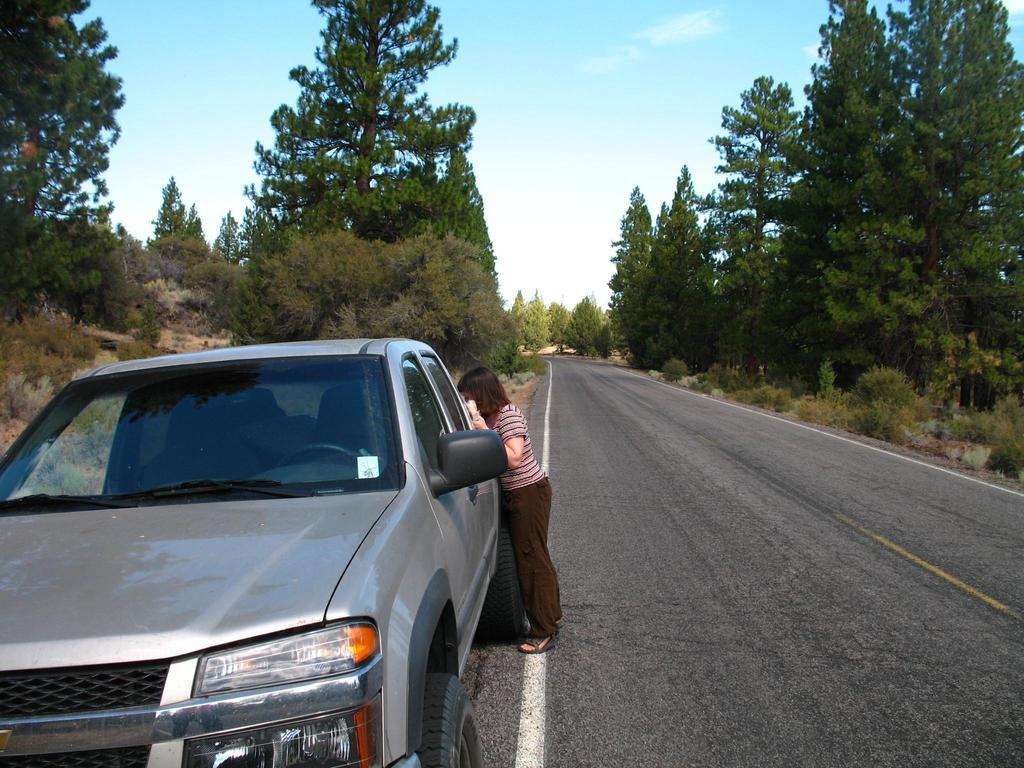What is located on the left side of the image? There is a car on the left side of the image. Where is the car positioned in relation to the road? The car is beside the road. Who is present near the car? A person is standing beside the car. What can be seen on both sides of the road? There are trees on both sides of the road. What is visible at the top of the image? The sky is visible at the top of the image. Can you tell me how many kitties are playing with the crook in the image? There are no kitties or crooks present in the image. Are there any dinosaurs visible in the image? There are no dinosaurs visible in the image. 